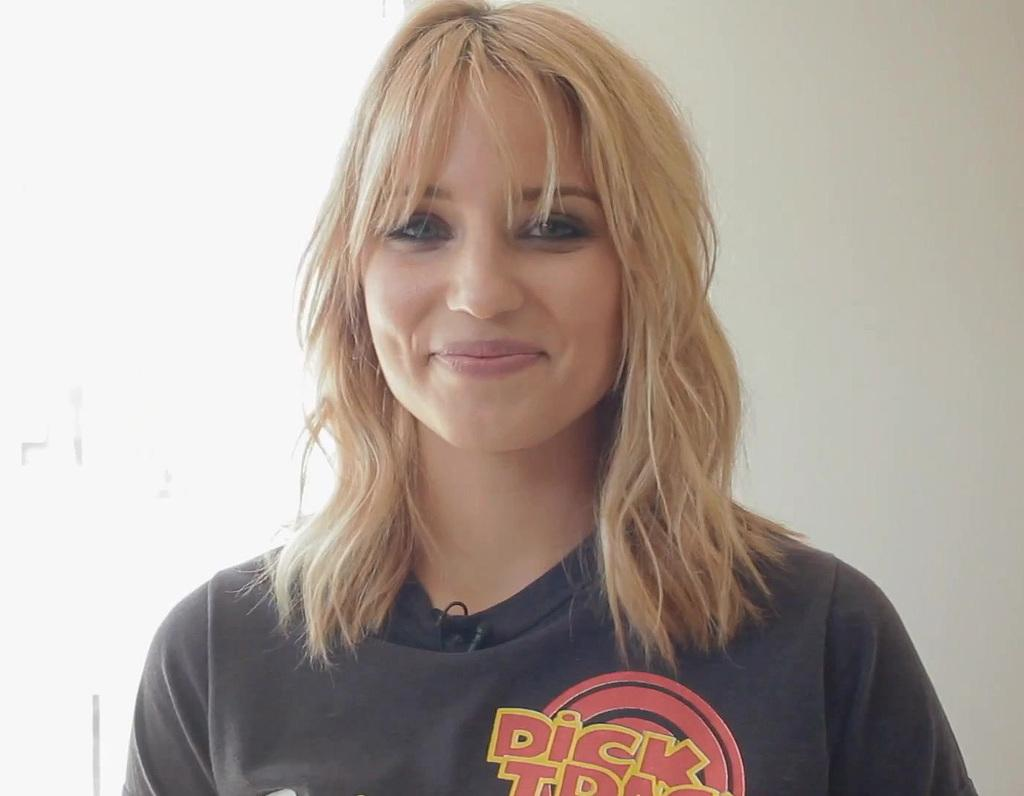What is the main subject of the image? The main subject of the image is a woman. Can you describe the woman's expression? The woman is smiling in the image. What is the woman wearing? The woman is wearing a black t-shirt. What can be seen in the background of the image? There is a wall in the background of the image. What type of bread is the woman holding in the image? There is no bread present in the image. Can you describe the door in the image? There is no door present in the image. 